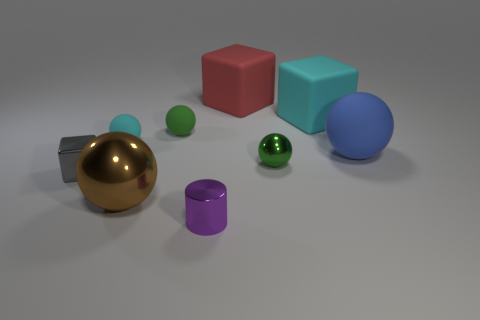Subtract all big matte cubes. How many cubes are left? 1 Subtract all cylinders. How many objects are left? 8 Subtract all red blocks. How many blocks are left? 2 Subtract 3 balls. How many balls are left? 2 Add 1 large shiny things. How many large shiny things exist? 2 Subtract 1 brown balls. How many objects are left? 8 Subtract all cyan cylinders. Subtract all yellow balls. How many cylinders are left? 1 Subtract all gray spheres. How many red blocks are left? 1 Subtract all green matte things. Subtract all brown spheres. How many objects are left? 7 Add 9 tiny green rubber balls. How many tiny green rubber balls are left? 10 